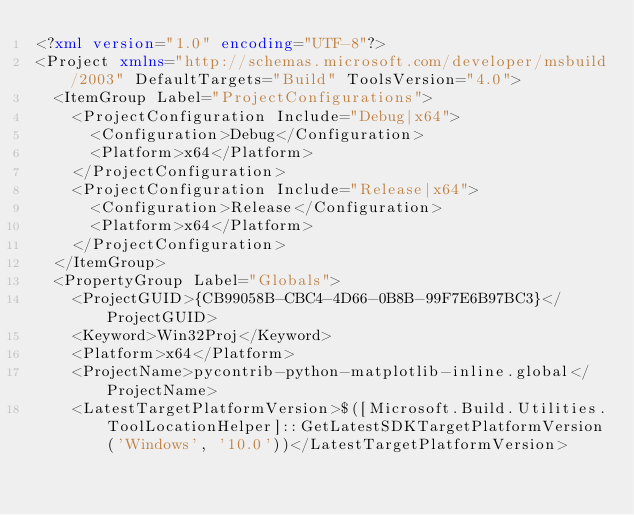Convert code to text. <code><loc_0><loc_0><loc_500><loc_500><_XML_><?xml version="1.0" encoding="UTF-8"?>
<Project xmlns="http://schemas.microsoft.com/developer/msbuild/2003" DefaultTargets="Build" ToolsVersion="4.0">
  <ItemGroup Label="ProjectConfigurations">
    <ProjectConfiguration Include="Debug|x64">
      <Configuration>Debug</Configuration>
      <Platform>x64</Platform>
    </ProjectConfiguration>
    <ProjectConfiguration Include="Release|x64">
      <Configuration>Release</Configuration>
      <Platform>x64</Platform>
    </ProjectConfiguration>
  </ItemGroup>
  <PropertyGroup Label="Globals">
    <ProjectGUID>{CB99058B-CBC4-4D66-0B8B-99F7E6B97BC3}</ProjectGUID>
    <Keyword>Win32Proj</Keyword>
    <Platform>x64</Platform>
    <ProjectName>pycontrib-python-matplotlib-inline.global</ProjectName>
    <LatestTargetPlatformVersion>$([Microsoft.Build.Utilities.ToolLocationHelper]::GetLatestSDKTargetPlatformVersion('Windows', '10.0'))</LatestTargetPlatformVersion></code> 